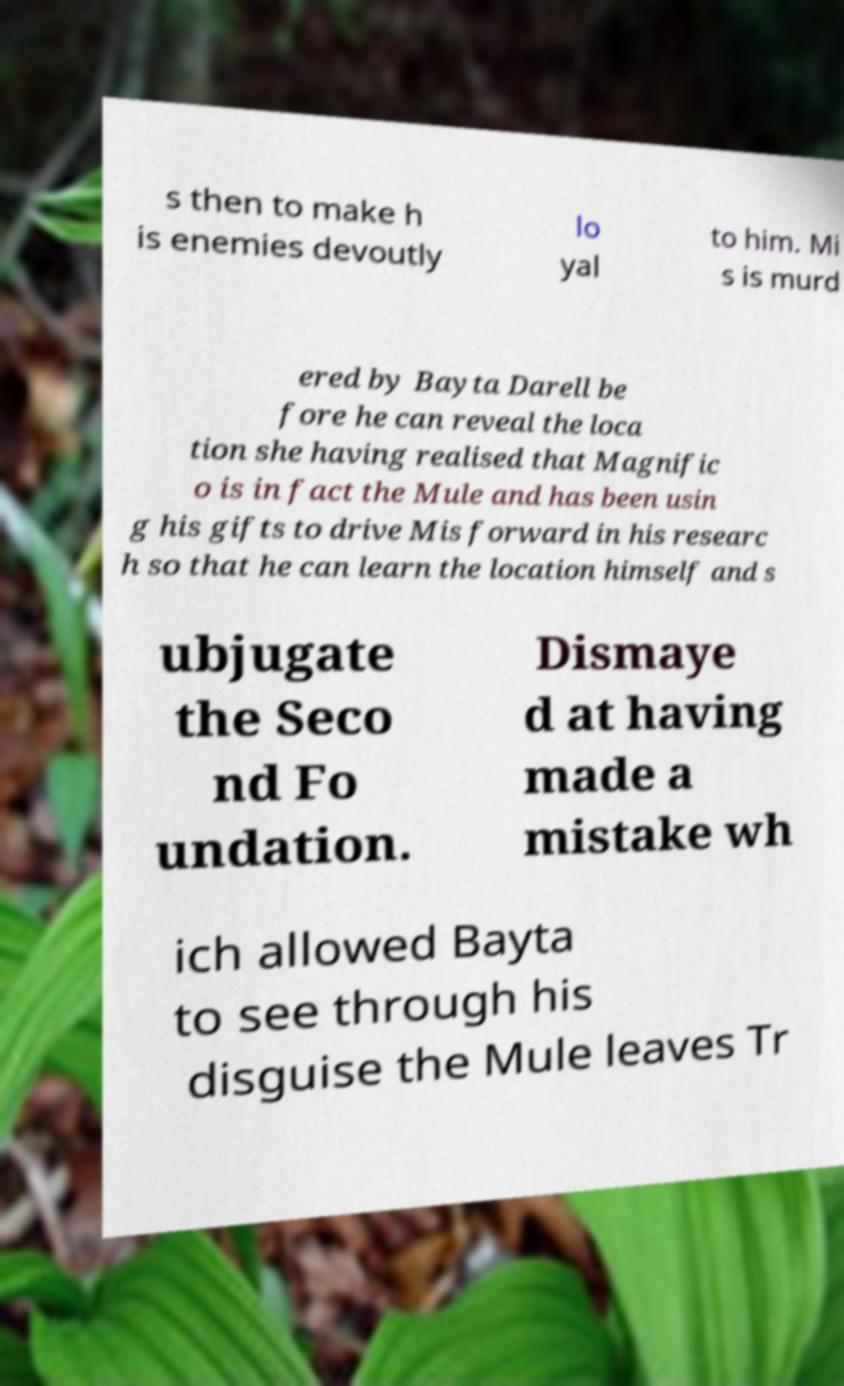Can you accurately transcribe the text from the provided image for me? s then to make h is enemies devoutly lo yal to him. Mi s is murd ered by Bayta Darell be fore he can reveal the loca tion she having realised that Magnific o is in fact the Mule and has been usin g his gifts to drive Mis forward in his researc h so that he can learn the location himself and s ubjugate the Seco nd Fo undation. Dismaye d at having made a mistake wh ich allowed Bayta to see through his disguise the Mule leaves Tr 